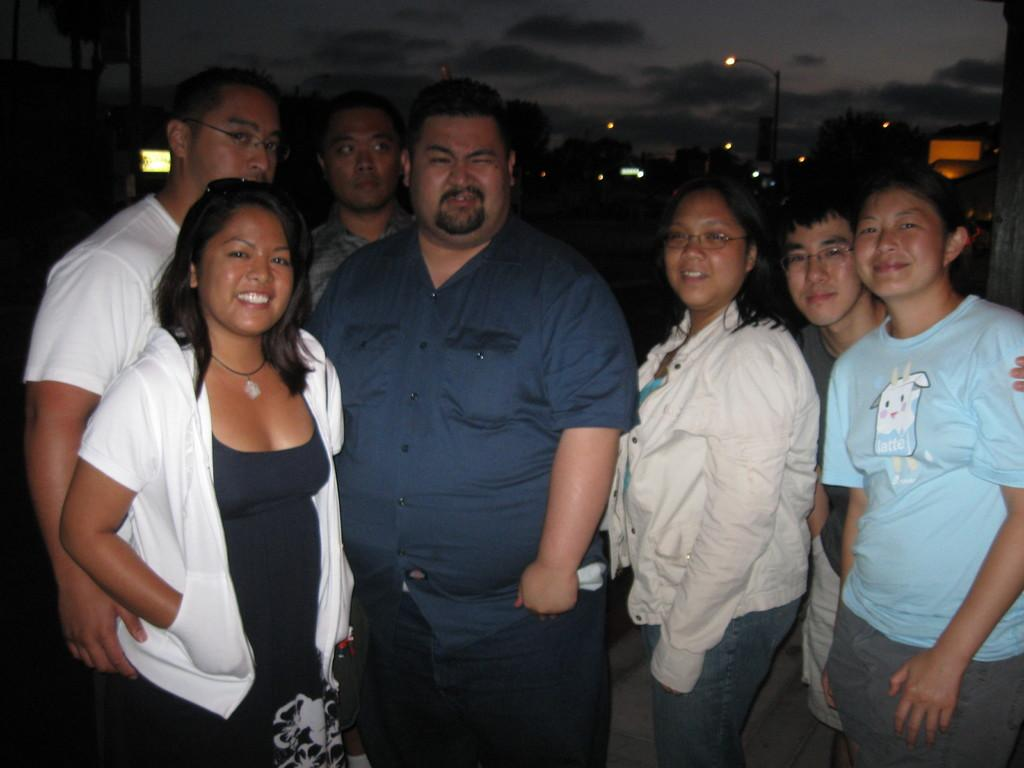How many persons are in the image? There are persons standing in the image. What is the color of the background in the image? The background of the image is dark. What can be seen in the background of the image? Trees, street lights, and other objects are visible in the background of the image. What is visible in the sky in the background of the image? Clouds are visible in the sky in the background of the image. What type of government is depicted in the image? There is no depiction of a government in the image; it features persons standing in a dark background with trees, street lights, and other objects visible. What riddle can be solved by looking at the pan in the image? There is no pan present in the image, so no riddle can be solved based on it. 